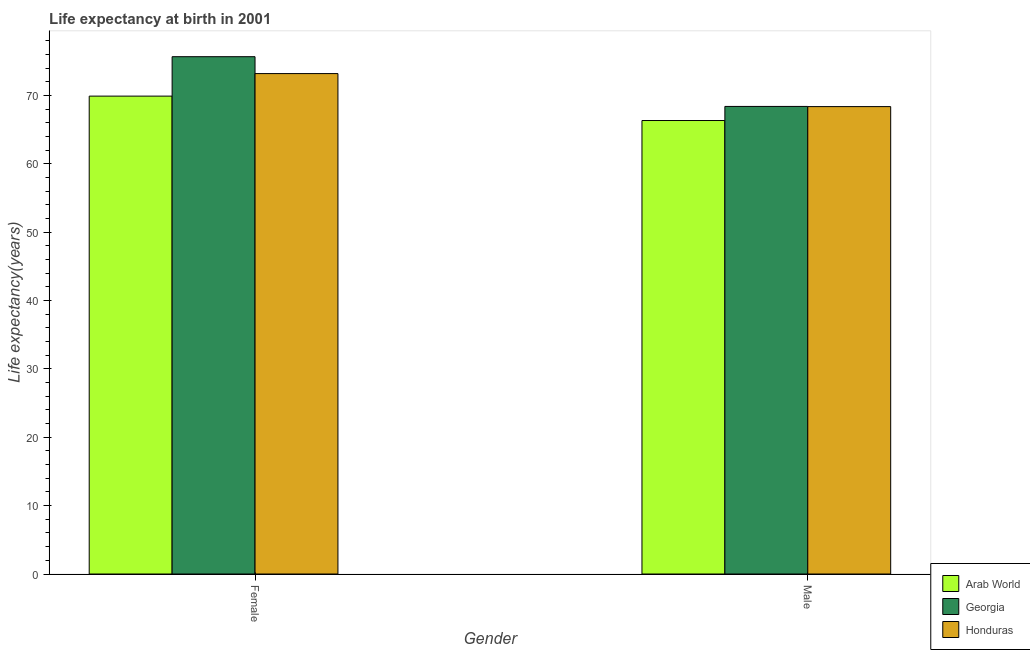What is the life expectancy(male) in Honduras?
Give a very brief answer. 68.36. Across all countries, what is the maximum life expectancy(female)?
Offer a very short reply. 75.66. Across all countries, what is the minimum life expectancy(male)?
Make the answer very short. 66.32. In which country was the life expectancy(female) maximum?
Keep it short and to the point. Georgia. In which country was the life expectancy(male) minimum?
Keep it short and to the point. Arab World. What is the total life expectancy(female) in the graph?
Make the answer very short. 218.73. What is the difference between the life expectancy(male) in Georgia and that in Honduras?
Give a very brief answer. 0.02. What is the difference between the life expectancy(male) in Honduras and the life expectancy(female) in Georgia?
Your answer should be compact. -7.3. What is the average life expectancy(male) per country?
Provide a short and direct response. 67.69. What is the difference between the life expectancy(male) and life expectancy(female) in Arab World?
Make the answer very short. -3.57. What is the ratio of the life expectancy(male) in Georgia to that in Honduras?
Your answer should be compact. 1. In how many countries, is the life expectancy(female) greater than the average life expectancy(female) taken over all countries?
Your answer should be very brief. 2. What does the 2nd bar from the left in Female represents?
Your response must be concise. Georgia. What does the 1st bar from the right in Female represents?
Your answer should be compact. Honduras. How many bars are there?
Provide a succinct answer. 6. How many countries are there in the graph?
Offer a terse response. 3. What is the difference between two consecutive major ticks on the Y-axis?
Keep it short and to the point. 10. Does the graph contain any zero values?
Ensure brevity in your answer.  No. How many legend labels are there?
Your answer should be very brief. 3. How are the legend labels stacked?
Offer a very short reply. Vertical. What is the title of the graph?
Your answer should be very brief. Life expectancy at birth in 2001. Does "Dominica" appear as one of the legend labels in the graph?
Keep it short and to the point. No. What is the label or title of the Y-axis?
Keep it short and to the point. Life expectancy(years). What is the Life expectancy(years) in Arab World in Female?
Your response must be concise. 69.89. What is the Life expectancy(years) in Georgia in Female?
Ensure brevity in your answer.  75.66. What is the Life expectancy(years) in Honduras in Female?
Your response must be concise. 73.19. What is the Life expectancy(years) of Arab World in Male?
Give a very brief answer. 66.32. What is the Life expectancy(years) in Georgia in Male?
Keep it short and to the point. 68.38. What is the Life expectancy(years) in Honduras in Male?
Make the answer very short. 68.36. Across all Gender, what is the maximum Life expectancy(years) of Arab World?
Give a very brief answer. 69.89. Across all Gender, what is the maximum Life expectancy(years) in Georgia?
Your answer should be compact. 75.66. Across all Gender, what is the maximum Life expectancy(years) of Honduras?
Keep it short and to the point. 73.19. Across all Gender, what is the minimum Life expectancy(years) of Arab World?
Make the answer very short. 66.32. Across all Gender, what is the minimum Life expectancy(years) of Georgia?
Give a very brief answer. 68.38. Across all Gender, what is the minimum Life expectancy(years) in Honduras?
Offer a very short reply. 68.36. What is the total Life expectancy(years) in Arab World in the graph?
Make the answer very short. 136.21. What is the total Life expectancy(years) in Georgia in the graph?
Provide a short and direct response. 144.04. What is the total Life expectancy(years) in Honduras in the graph?
Give a very brief answer. 141.54. What is the difference between the Life expectancy(years) in Arab World in Female and that in Male?
Make the answer very short. 3.57. What is the difference between the Life expectancy(years) in Georgia in Female and that in Male?
Your answer should be very brief. 7.28. What is the difference between the Life expectancy(years) of Honduras in Female and that in Male?
Ensure brevity in your answer.  4.83. What is the difference between the Life expectancy(years) of Arab World in Female and the Life expectancy(years) of Georgia in Male?
Provide a short and direct response. 1.51. What is the difference between the Life expectancy(years) in Arab World in Female and the Life expectancy(years) in Honduras in Male?
Offer a very short reply. 1.53. What is the difference between the Life expectancy(years) of Georgia in Female and the Life expectancy(years) of Honduras in Male?
Your answer should be compact. 7.3. What is the average Life expectancy(years) of Arab World per Gender?
Your response must be concise. 68.11. What is the average Life expectancy(years) of Georgia per Gender?
Give a very brief answer. 72.02. What is the average Life expectancy(years) of Honduras per Gender?
Keep it short and to the point. 70.77. What is the difference between the Life expectancy(years) in Arab World and Life expectancy(years) in Georgia in Female?
Make the answer very short. -5.77. What is the difference between the Life expectancy(years) of Arab World and Life expectancy(years) of Honduras in Female?
Make the answer very short. -3.29. What is the difference between the Life expectancy(years) of Georgia and Life expectancy(years) of Honduras in Female?
Provide a short and direct response. 2.47. What is the difference between the Life expectancy(years) of Arab World and Life expectancy(years) of Georgia in Male?
Give a very brief answer. -2.06. What is the difference between the Life expectancy(years) in Arab World and Life expectancy(years) in Honduras in Male?
Keep it short and to the point. -2.04. What is the difference between the Life expectancy(years) of Georgia and Life expectancy(years) of Honduras in Male?
Provide a succinct answer. 0.02. What is the ratio of the Life expectancy(years) in Arab World in Female to that in Male?
Provide a succinct answer. 1.05. What is the ratio of the Life expectancy(years) in Georgia in Female to that in Male?
Offer a terse response. 1.11. What is the ratio of the Life expectancy(years) of Honduras in Female to that in Male?
Your answer should be very brief. 1.07. What is the difference between the highest and the second highest Life expectancy(years) of Arab World?
Offer a terse response. 3.57. What is the difference between the highest and the second highest Life expectancy(years) of Georgia?
Your response must be concise. 7.28. What is the difference between the highest and the second highest Life expectancy(years) in Honduras?
Offer a terse response. 4.83. What is the difference between the highest and the lowest Life expectancy(years) of Arab World?
Make the answer very short. 3.57. What is the difference between the highest and the lowest Life expectancy(years) of Georgia?
Offer a very short reply. 7.28. What is the difference between the highest and the lowest Life expectancy(years) of Honduras?
Your answer should be compact. 4.83. 